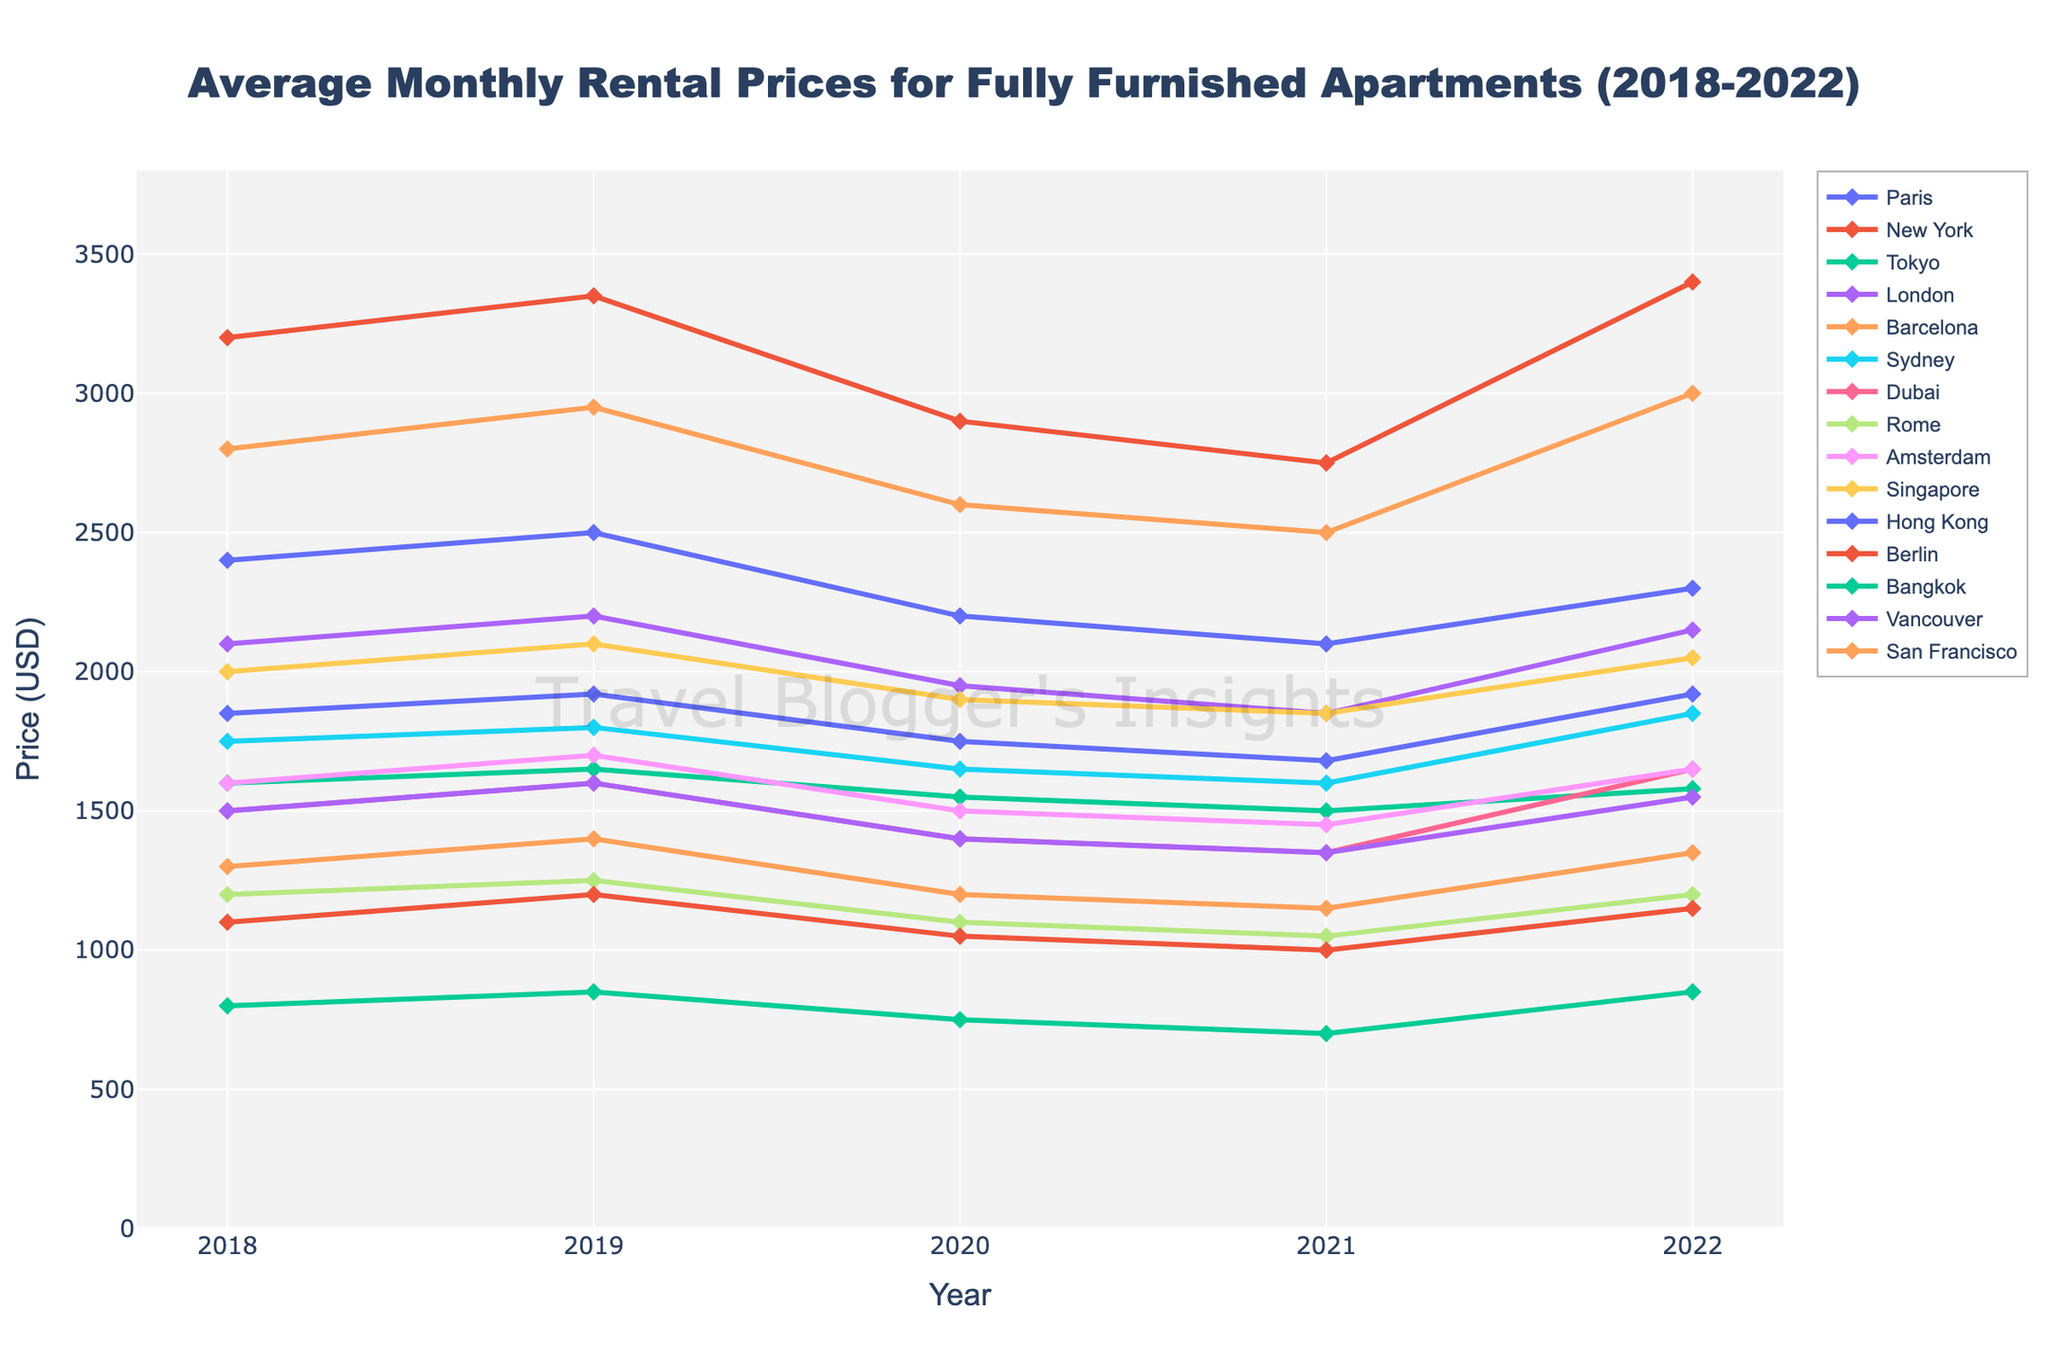What's the average rental price for New York over the 5 years? First, sum the rental prices for New York from 2018 to 2022: 3200 + 3350 + 2900 + 2750 + 3400 = 15600. Then, divide this by the number of years, which is 5. So, 15600/5 = 3120
Answer: 3120 Which city had the lowest rental price in 2021? By looking at the 2021 data, the lowest rental price is 700, which belongs to Bangkok
Answer: Bangkok How much did the rental price in San Francisco change from 2018 to 2022? The price in San Francisco in 2018 was 2800 and in 2022 it was 3000. So, the change is 3000 - 2800 = 200
Answer: 200 Which city experienced the largest decline in rental prices from 2019 to 2020? By calculating the price changes from 2019 to 2020, New York had the largest decline: 3350 - 2900 = 450
Answer: New York Between which years did Tokyo see the most significant drop in rental price? Tokyo's prices dropped most significantly between 2019 and 2020: 1650 - 1550 = 100
Answer: 2019 to 2020 Which city's rental prices peaked in 2019 and then decreased in the subsequent years? Paris had its peak in 2019 at 1920 and decreased in 2020 and 2021
Answer: Paris How many cities had a rental price below 1400 in 2020? The cities with rental prices below 1400 in 2020 are Tokyo (1550), Barcelona (1200), Dubai (1400), Rome (1100), Amsterdam (1500), Berlin (1050), and Bangkok (750), which totals 7 cities
Answer: 7 In 2022, which city had a higher rental price: Hong Kong or San Francisco? Comparing the rental prices in 2022, Hong Kong had a price of 2300 while San Francisco had a price of 3000. Therefore, San Francisco had the higher price
Answer: San Francisco Which city saw the highest overall increase in rental price from 2021 to 2022? To determine the highest increase, look for the difference between 2021 and 2022 prices. New York saw the largest increase: 3400 - 2750 = 650
Answer: New York Which cities had consistent rental prices (either no increase or no decrease) from 2018 to 2022? There are no cities with consistent prices across all five years indicated in the dataset
Answer: None 